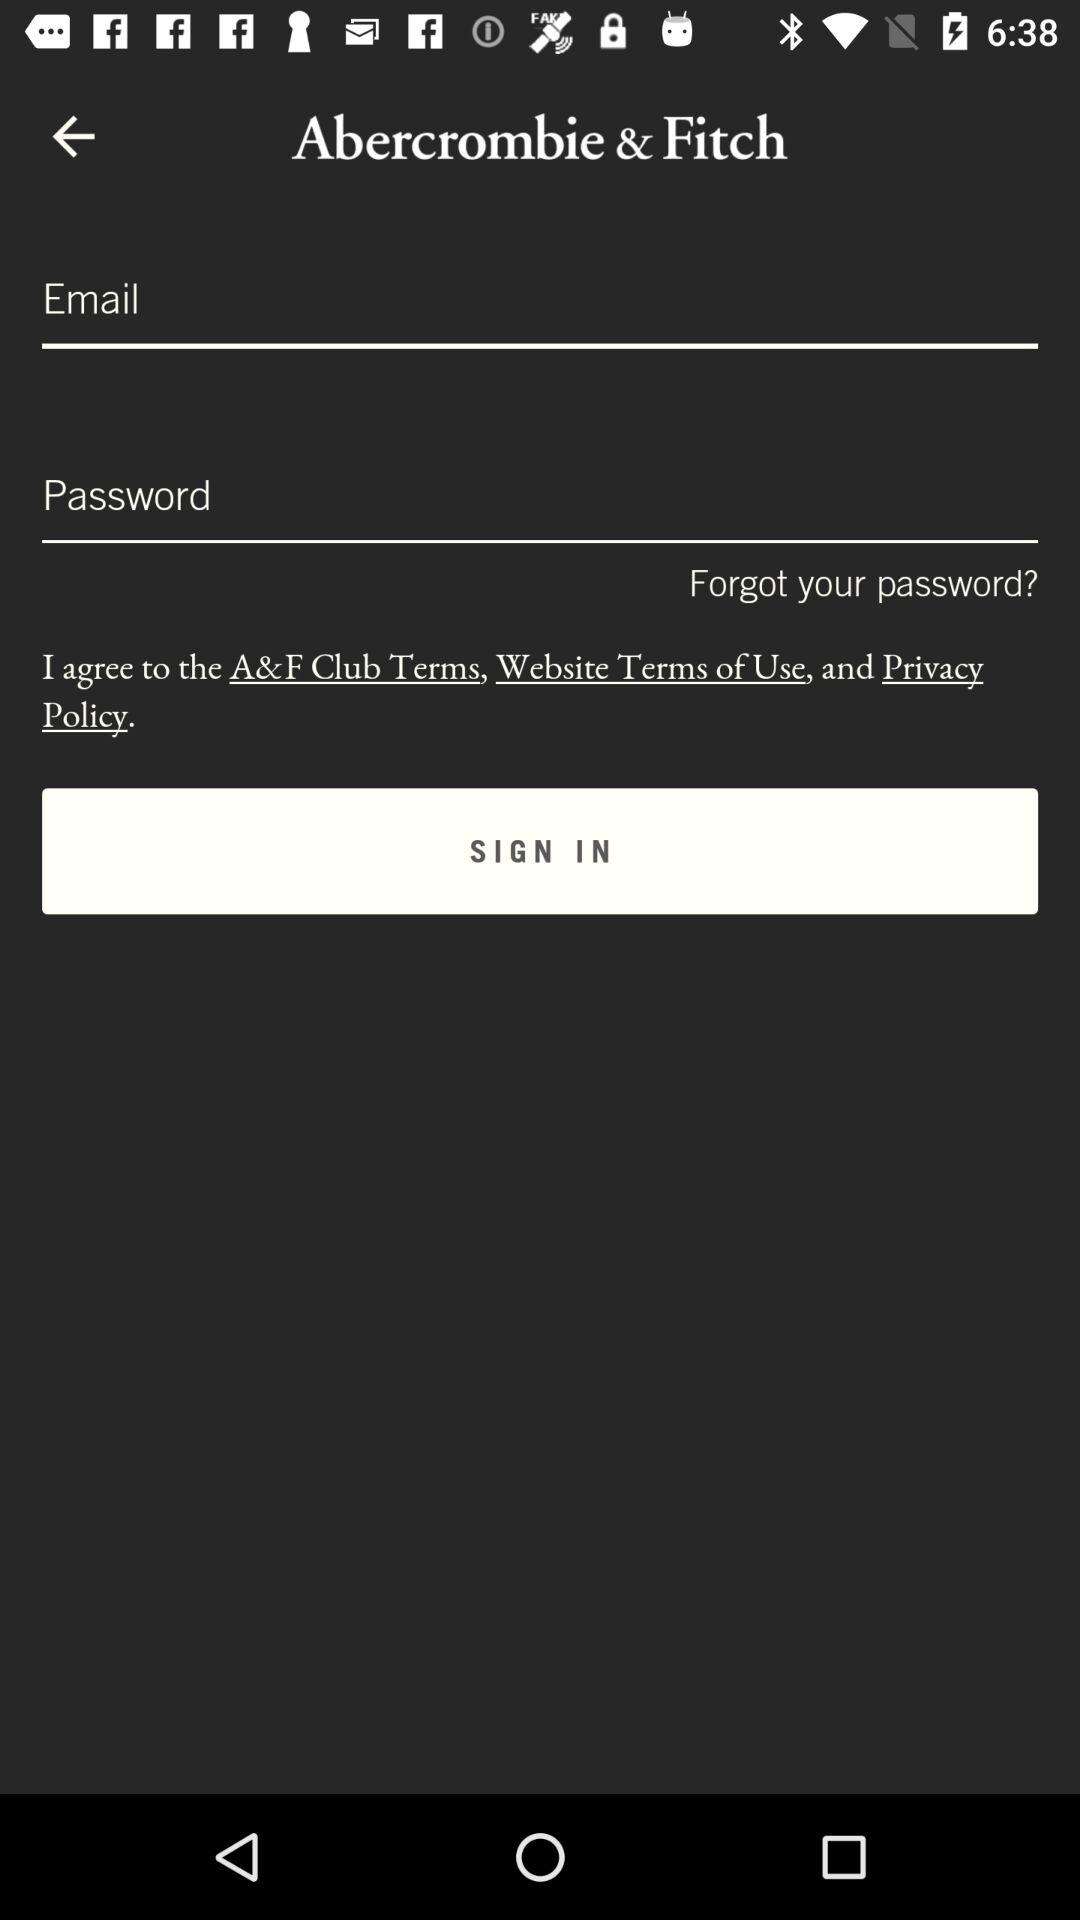What is the entered email address?
When the provided information is insufficient, respond with <no answer>. <no answer> 